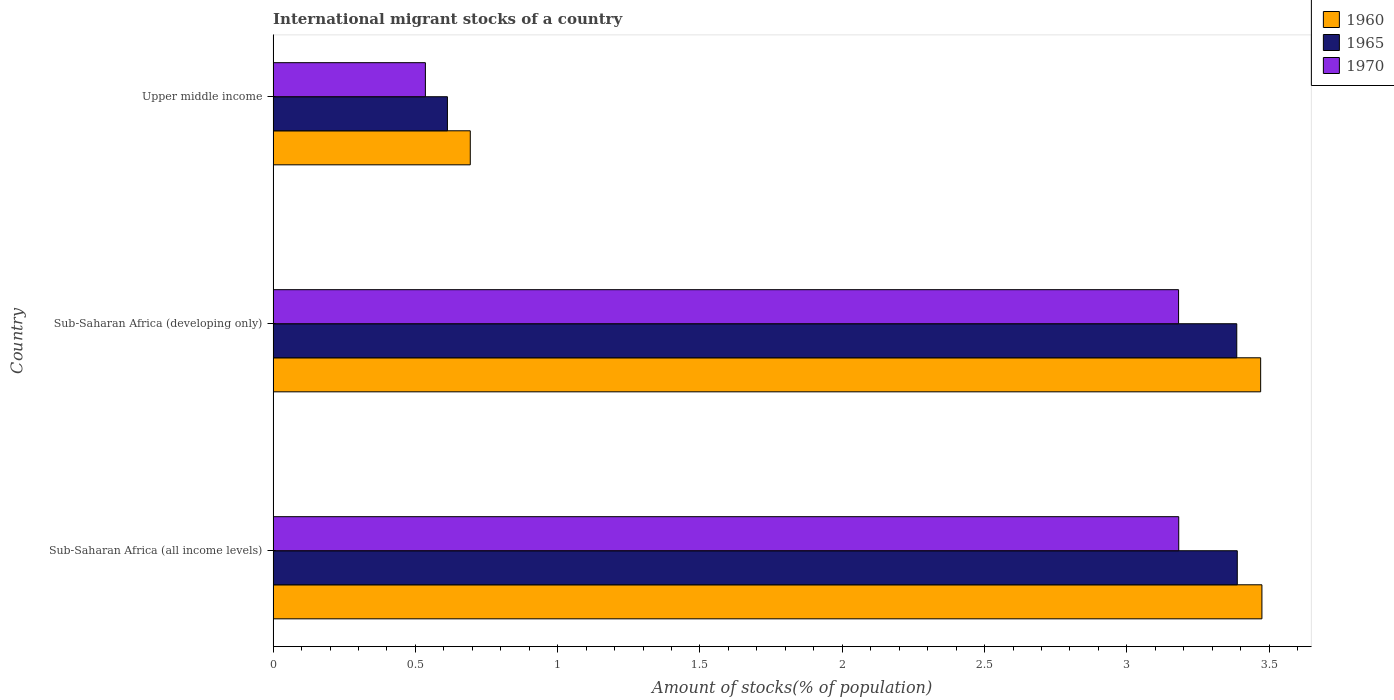Are the number of bars per tick equal to the number of legend labels?
Your answer should be very brief. Yes. Are the number of bars on each tick of the Y-axis equal?
Make the answer very short. Yes. How many bars are there on the 3rd tick from the top?
Keep it short and to the point. 3. How many bars are there on the 3rd tick from the bottom?
Your response must be concise. 3. What is the label of the 3rd group of bars from the top?
Your answer should be compact. Sub-Saharan Africa (all income levels). In how many cases, is the number of bars for a given country not equal to the number of legend labels?
Your response must be concise. 0. What is the amount of stocks in in 1965 in Sub-Saharan Africa (developing only)?
Provide a short and direct response. 3.39. Across all countries, what is the maximum amount of stocks in in 1960?
Offer a very short reply. 3.47. Across all countries, what is the minimum amount of stocks in in 1960?
Ensure brevity in your answer.  0.69. In which country was the amount of stocks in in 1960 maximum?
Offer a terse response. Sub-Saharan Africa (all income levels). In which country was the amount of stocks in in 1965 minimum?
Your answer should be compact. Upper middle income. What is the total amount of stocks in in 1970 in the graph?
Make the answer very short. 6.9. What is the difference between the amount of stocks in in 1970 in Sub-Saharan Africa (developing only) and that in Upper middle income?
Offer a terse response. 2.65. What is the difference between the amount of stocks in in 1960 in Upper middle income and the amount of stocks in in 1970 in Sub-Saharan Africa (developing only)?
Provide a short and direct response. -2.49. What is the average amount of stocks in in 1970 per country?
Offer a very short reply. 2.3. What is the difference between the amount of stocks in in 1960 and amount of stocks in in 1965 in Sub-Saharan Africa (all income levels)?
Your answer should be very brief. 0.09. In how many countries, is the amount of stocks in in 1970 greater than 2.2 %?
Offer a terse response. 2. What is the ratio of the amount of stocks in in 1965 in Sub-Saharan Africa (all income levels) to that in Upper middle income?
Ensure brevity in your answer.  5.53. Is the amount of stocks in in 1970 in Sub-Saharan Africa (all income levels) less than that in Sub-Saharan Africa (developing only)?
Your answer should be very brief. No. What is the difference between the highest and the second highest amount of stocks in in 1960?
Provide a succinct answer. 0. What is the difference between the highest and the lowest amount of stocks in in 1960?
Provide a short and direct response. 2.78. In how many countries, is the amount of stocks in in 1970 greater than the average amount of stocks in in 1970 taken over all countries?
Your answer should be very brief. 2. What does the 3rd bar from the top in Upper middle income represents?
Keep it short and to the point. 1960. What does the 2nd bar from the bottom in Sub-Saharan Africa (all income levels) represents?
Offer a very short reply. 1965. Is it the case that in every country, the sum of the amount of stocks in in 1970 and amount of stocks in in 1965 is greater than the amount of stocks in in 1960?
Offer a terse response. Yes. Are all the bars in the graph horizontal?
Offer a very short reply. Yes. How many countries are there in the graph?
Ensure brevity in your answer.  3. Does the graph contain any zero values?
Offer a very short reply. No. How many legend labels are there?
Give a very brief answer. 3. What is the title of the graph?
Make the answer very short. International migrant stocks of a country. Does "1985" appear as one of the legend labels in the graph?
Offer a very short reply. No. What is the label or title of the X-axis?
Your answer should be very brief. Amount of stocks(% of population). What is the Amount of stocks(% of population) in 1960 in Sub-Saharan Africa (all income levels)?
Give a very brief answer. 3.47. What is the Amount of stocks(% of population) of 1965 in Sub-Saharan Africa (all income levels)?
Provide a succinct answer. 3.39. What is the Amount of stocks(% of population) in 1970 in Sub-Saharan Africa (all income levels)?
Offer a very short reply. 3.18. What is the Amount of stocks(% of population) in 1960 in Sub-Saharan Africa (developing only)?
Provide a short and direct response. 3.47. What is the Amount of stocks(% of population) of 1965 in Sub-Saharan Africa (developing only)?
Your response must be concise. 3.39. What is the Amount of stocks(% of population) of 1970 in Sub-Saharan Africa (developing only)?
Your answer should be compact. 3.18. What is the Amount of stocks(% of population) in 1960 in Upper middle income?
Make the answer very short. 0.69. What is the Amount of stocks(% of population) of 1965 in Upper middle income?
Your answer should be compact. 0.61. What is the Amount of stocks(% of population) in 1970 in Upper middle income?
Offer a very short reply. 0.54. Across all countries, what is the maximum Amount of stocks(% of population) in 1960?
Offer a terse response. 3.47. Across all countries, what is the maximum Amount of stocks(% of population) of 1965?
Your response must be concise. 3.39. Across all countries, what is the maximum Amount of stocks(% of population) of 1970?
Keep it short and to the point. 3.18. Across all countries, what is the minimum Amount of stocks(% of population) of 1960?
Offer a terse response. 0.69. Across all countries, what is the minimum Amount of stocks(% of population) of 1965?
Keep it short and to the point. 0.61. Across all countries, what is the minimum Amount of stocks(% of population) of 1970?
Your answer should be compact. 0.54. What is the total Amount of stocks(% of population) in 1960 in the graph?
Keep it short and to the point. 7.64. What is the total Amount of stocks(% of population) of 1965 in the graph?
Keep it short and to the point. 7.39. What is the total Amount of stocks(% of population) in 1970 in the graph?
Provide a short and direct response. 6.9. What is the difference between the Amount of stocks(% of population) of 1960 in Sub-Saharan Africa (all income levels) and that in Sub-Saharan Africa (developing only)?
Your response must be concise. 0. What is the difference between the Amount of stocks(% of population) of 1965 in Sub-Saharan Africa (all income levels) and that in Sub-Saharan Africa (developing only)?
Your response must be concise. 0. What is the difference between the Amount of stocks(% of population) in 1970 in Sub-Saharan Africa (all income levels) and that in Sub-Saharan Africa (developing only)?
Offer a very short reply. 0. What is the difference between the Amount of stocks(% of population) of 1960 in Sub-Saharan Africa (all income levels) and that in Upper middle income?
Provide a succinct answer. 2.78. What is the difference between the Amount of stocks(% of population) in 1965 in Sub-Saharan Africa (all income levels) and that in Upper middle income?
Your answer should be compact. 2.78. What is the difference between the Amount of stocks(% of population) of 1970 in Sub-Saharan Africa (all income levels) and that in Upper middle income?
Your answer should be compact. 2.65. What is the difference between the Amount of stocks(% of population) of 1960 in Sub-Saharan Africa (developing only) and that in Upper middle income?
Keep it short and to the point. 2.78. What is the difference between the Amount of stocks(% of population) in 1965 in Sub-Saharan Africa (developing only) and that in Upper middle income?
Offer a very short reply. 2.77. What is the difference between the Amount of stocks(% of population) in 1970 in Sub-Saharan Africa (developing only) and that in Upper middle income?
Provide a succinct answer. 2.65. What is the difference between the Amount of stocks(% of population) of 1960 in Sub-Saharan Africa (all income levels) and the Amount of stocks(% of population) of 1965 in Sub-Saharan Africa (developing only)?
Make the answer very short. 0.09. What is the difference between the Amount of stocks(% of population) of 1960 in Sub-Saharan Africa (all income levels) and the Amount of stocks(% of population) of 1970 in Sub-Saharan Africa (developing only)?
Offer a terse response. 0.29. What is the difference between the Amount of stocks(% of population) of 1965 in Sub-Saharan Africa (all income levels) and the Amount of stocks(% of population) of 1970 in Sub-Saharan Africa (developing only)?
Offer a terse response. 0.21. What is the difference between the Amount of stocks(% of population) in 1960 in Sub-Saharan Africa (all income levels) and the Amount of stocks(% of population) in 1965 in Upper middle income?
Provide a short and direct response. 2.86. What is the difference between the Amount of stocks(% of population) in 1960 in Sub-Saharan Africa (all income levels) and the Amount of stocks(% of population) in 1970 in Upper middle income?
Offer a very short reply. 2.94. What is the difference between the Amount of stocks(% of population) of 1965 in Sub-Saharan Africa (all income levels) and the Amount of stocks(% of population) of 1970 in Upper middle income?
Provide a succinct answer. 2.85. What is the difference between the Amount of stocks(% of population) of 1960 in Sub-Saharan Africa (developing only) and the Amount of stocks(% of population) of 1965 in Upper middle income?
Provide a succinct answer. 2.86. What is the difference between the Amount of stocks(% of population) of 1960 in Sub-Saharan Africa (developing only) and the Amount of stocks(% of population) of 1970 in Upper middle income?
Offer a very short reply. 2.94. What is the difference between the Amount of stocks(% of population) in 1965 in Sub-Saharan Africa (developing only) and the Amount of stocks(% of population) in 1970 in Upper middle income?
Your answer should be very brief. 2.85. What is the average Amount of stocks(% of population) in 1960 per country?
Give a very brief answer. 2.55. What is the average Amount of stocks(% of population) in 1965 per country?
Provide a succinct answer. 2.46. What is the average Amount of stocks(% of population) of 1970 per country?
Offer a very short reply. 2.3. What is the difference between the Amount of stocks(% of population) in 1960 and Amount of stocks(% of population) in 1965 in Sub-Saharan Africa (all income levels)?
Provide a succinct answer. 0.09. What is the difference between the Amount of stocks(% of population) of 1960 and Amount of stocks(% of population) of 1970 in Sub-Saharan Africa (all income levels)?
Provide a succinct answer. 0.29. What is the difference between the Amount of stocks(% of population) in 1965 and Amount of stocks(% of population) in 1970 in Sub-Saharan Africa (all income levels)?
Offer a very short reply. 0.21. What is the difference between the Amount of stocks(% of population) of 1960 and Amount of stocks(% of population) of 1965 in Sub-Saharan Africa (developing only)?
Offer a very short reply. 0.08. What is the difference between the Amount of stocks(% of population) in 1960 and Amount of stocks(% of population) in 1970 in Sub-Saharan Africa (developing only)?
Keep it short and to the point. 0.29. What is the difference between the Amount of stocks(% of population) of 1965 and Amount of stocks(% of population) of 1970 in Sub-Saharan Africa (developing only)?
Provide a succinct answer. 0.2. What is the difference between the Amount of stocks(% of population) of 1960 and Amount of stocks(% of population) of 1965 in Upper middle income?
Give a very brief answer. 0.08. What is the difference between the Amount of stocks(% of population) of 1960 and Amount of stocks(% of population) of 1970 in Upper middle income?
Keep it short and to the point. 0.16. What is the difference between the Amount of stocks(% of population) of 1965 and Amount of stocks(% of population) of 1970 in Upper middle income?
Keep it short and to the point. 0.08. What is the ratio of the Amount of stocks(% of population) in 1965 in Sub-Saharan Africa (all income levels) to that in Sub-Saharan Africa (developing only)?
Give a very brief answer. 1. What is the ratio of the Amount of stocks(% of population) of 1970 in Sub-Saharan Africa (all income levels) to that in Sub-Saharan Africa (developing only)?
Keep it short and to the point. 1. What is the ratio of the Amount of stocks(% of population) of 1960 in Sub-Saharan Africa (all income levels) to that in Upper middle income?
Your response must be concise. 5.02. What is the ratio of the Amount of stocks(% of population) in 1965 in Sub-Saharan Africa (all income levels) to that in Upper middle income?
Your answer should be very brief. 5.53. What is the ratio of the Amount of stocks(% of population) in 1970 in Sub-Saharan Africa (all income levels) to that in Upper middle income?
Provide a succinct answer. 5.95. What is the ratio of the Amount of stocks(% of population) of 1960 in Sub-Saharan Africa (developing only) to that in Upper middle income?
Offer a very short reply. 5.01. What is the ratio of the Amount of stocks(% of population) in 1965 in Sub-Saharan Africa (developing only) to that in Upper middle income?
Offer a terse response. 5.53. What is the ratio of the Amount of stocks(% of population) of 1970 in Sub-Saharan Africa (developing only) to that in Upper middle income?
Offer a terse response. 5.95. What is the difference between the highest and the second highest Amount of stocks(% of population) in 1960?
Ensure brevity in your answer.  0. What is the difference between the highest and the second highest Amount of stocks(% of population) in 1965?
Your response must be concise. 0. What is the difference between the highest and the second highest Amount of stocks(% of population) of 1970?
Provide a succinct answer. 0. What is the difference between the highest and the lowest Amount of stocks(% of population) in 1960?
Your answer should be very brief. 2.78. What is the difference between the highest and the lowest Amount of stocks(% of population) of 1965?
Your answer should be compact. 2.78. What is the difference between the highest and the lowest Amount of stocks(% of population) of 1970?
Give a very brief answer. 2.65. 